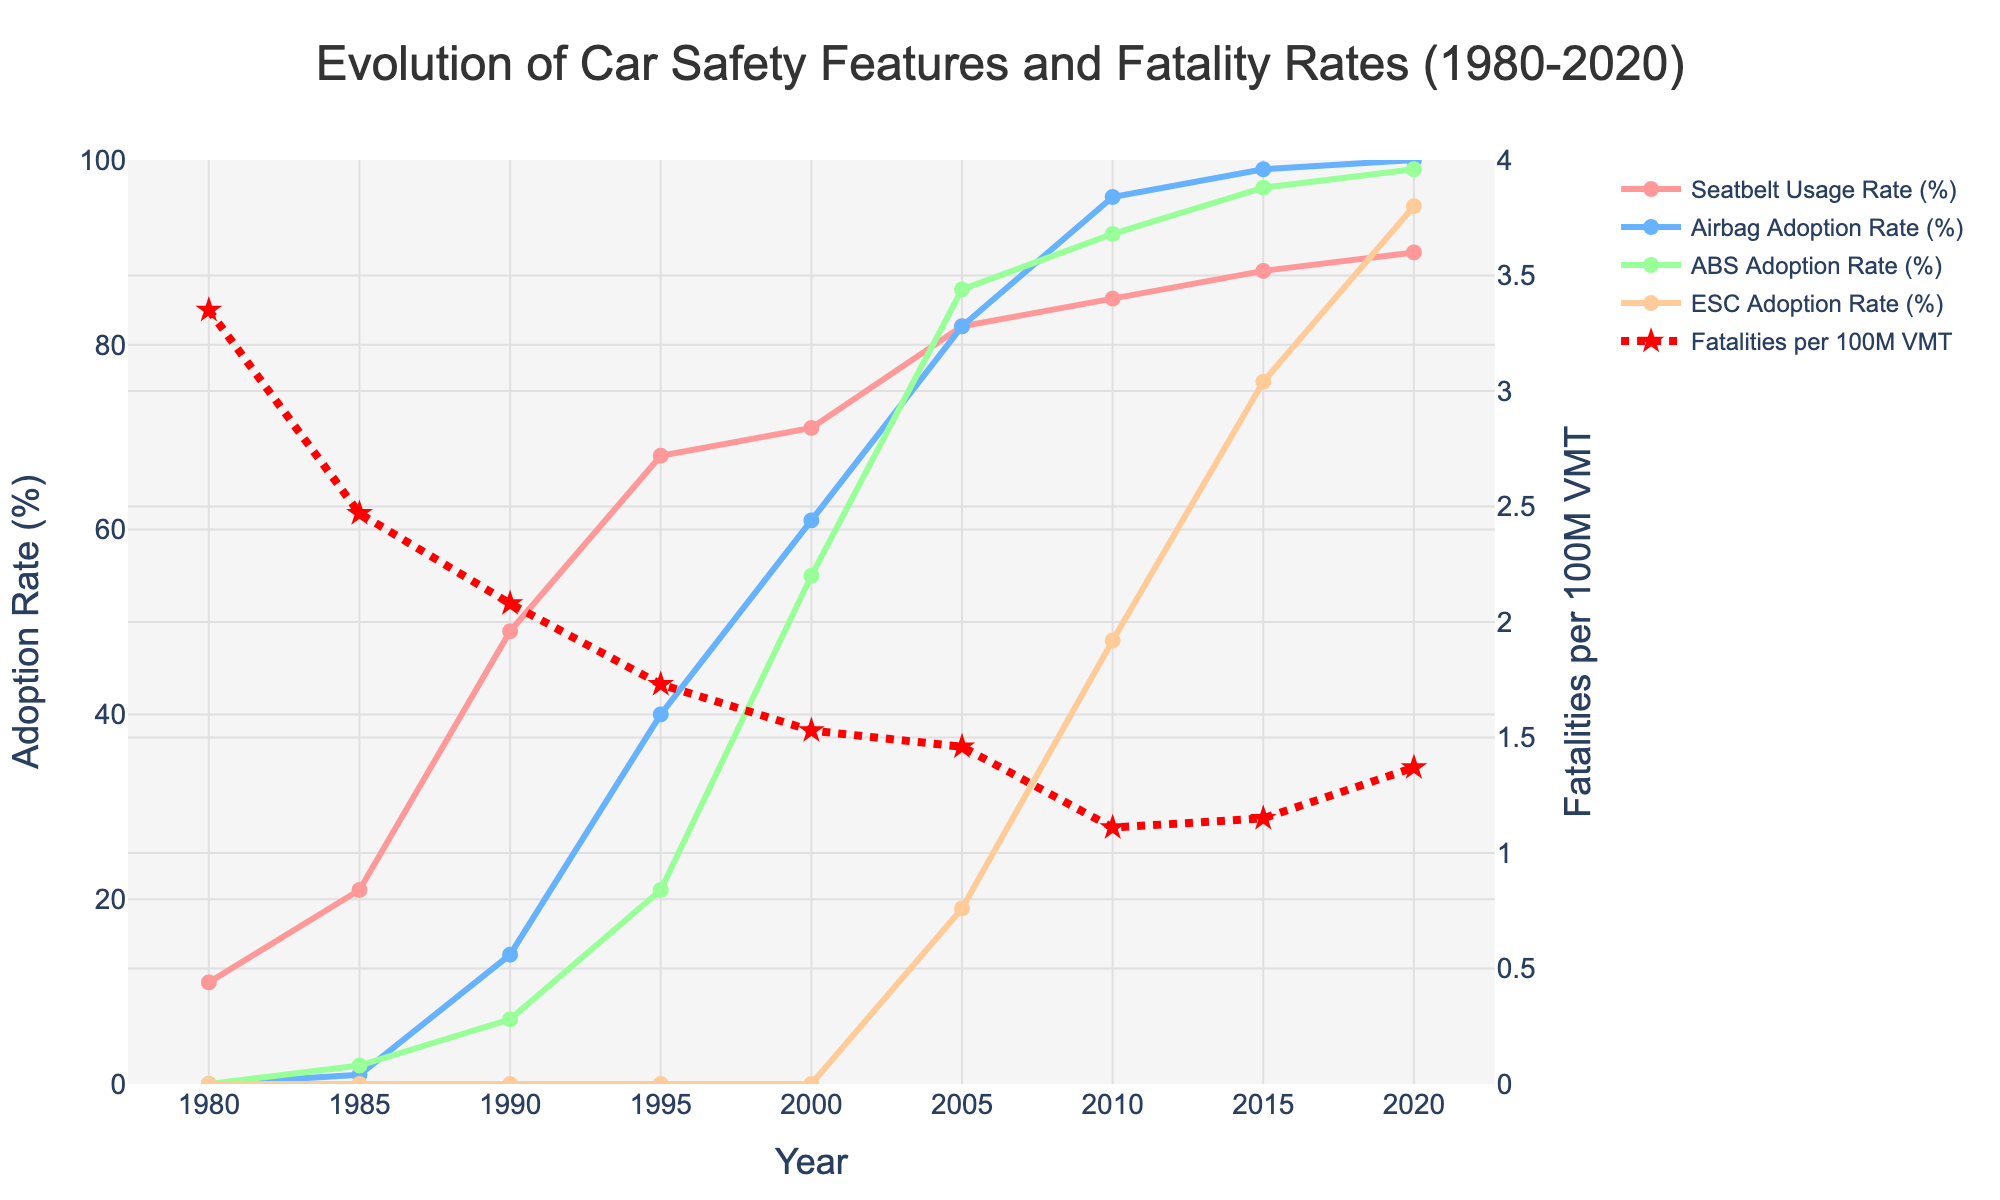Which year had the highest Seatbelt Usage Rate? The Seatbelt Usage Rate for each year can be seen by looking at the green line. The highest point for this line occurs in 2020.
Answer: 2020 Which safety feature had a continuous increase over the entire period from 1980 to 2020? Observing the lines for each safety feature, Seatbelt Usage Rate, Airbag Adoption Rate, ABS Adoption Rate, and ESC Adoption Rate, we see that the Airbag Adoption Rate (blue line) increased continuously throughout the period.
Answer: Airbag Adoption Rate What was the Fatalities per 100M VMT in 2005? The red dotted line represents Fatalities per 100M VMT. By finding the position corresponding to the year 2005, we can read the value directly off the chart.
Answer: 1.46 How much did the Fatalities per 100M VMT decrease from 1980 to 2010? We need to find the Fatalities per 100M VMT values for 1980 and 2010, then calculate the difference: 3.35 (1980) - 1.11 (2010) = 2.24.
Answer: 2.24 What year did ESC Adoption Rate start being recorded? By referring to the orange line for ESC Adoption Rate, we see that it starts appearing on the graph in 2005.
Answer: 2005 What is the average Seatbelt Usage Rate from 1980 to 2020? We need to sum the Seatbelt Usage Rate values from 1980 to 2020 and divide by the number of years: (11 + 21 + 49 + 68 + 71 + 82 + 85 + 88 + 90) / 9.
Answer: 62.78 Which safety feature had the fastest growth rate between 1990 and 2000? By examining the slopes of the lines between 1990 and 2000, the Airbag Adoption Rate (blue line) shows the steepest increase, going from 14% to 61%.
Answer: Airbag Adoption Rate In which year did the Fatalities per 100M VMT reach its lowest point? The lowest point on the red dotted line represents the lowest Fatalities per 100M VMT, occurring in 2010.
Answer: 2010 